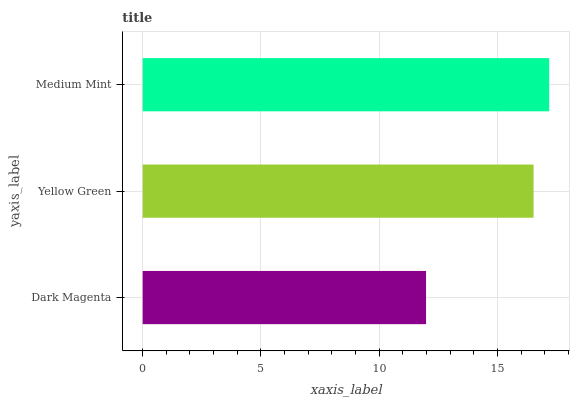Is Dark Magenta the minimum?
Answer yes or no. Yes. Is Medium Mint the maximum?
Answer yes or no. Yes. Is Yellow Green the minimum?
Answer yes or no. No. Is Yellow Green the maximum?
Answer yes or no. No. Is Yellow Green greater than Dark Magenta?
Answer yes or no. Yes. Is Dark Magenta less than Yellow Green?
Answer yes or no. Yes. Is Dark Magenta greater than Yellow Green?
Answer yes or no. No. Is Yellow Green less than Dark Magenta?
Answer yes or no. No. Is Yellow Green the high median?
Answer yes or no. Yes. Is Yellow Green the low median?
Answer yes or no. Yes. Is Medium Mint the high median?
Answer yes or no. No. Is Dark Magenta the low median?
Answer yes or no. No. 